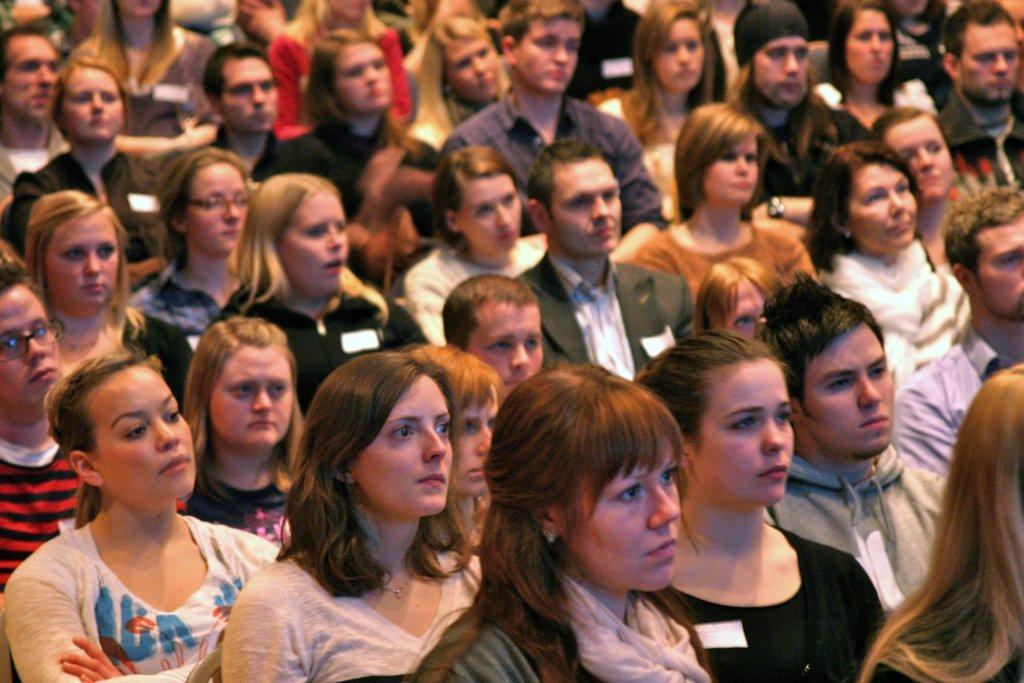Could you give a brief overview of what you see in this image? In this picture I can see few people seated. 